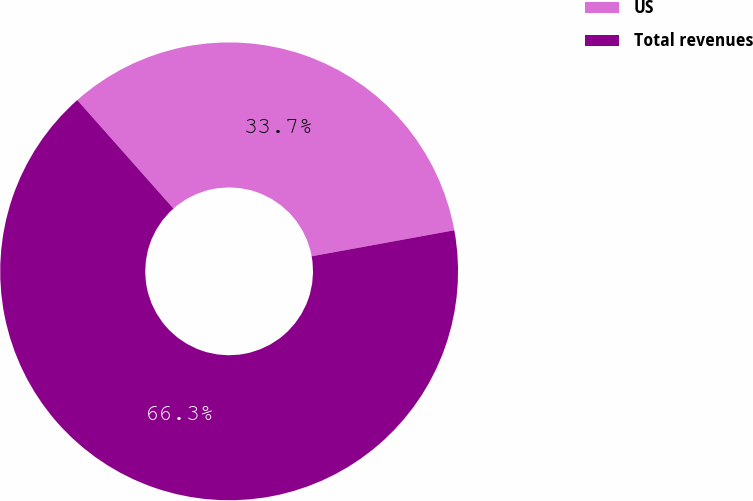Convert chart. <chart><loc_0><loc_0><loc_500><loc_500><pie_chart><fcel>US<fcel>Total revenues<nl><fcel>33.67%<fcel>66.33%<nl></chart> 